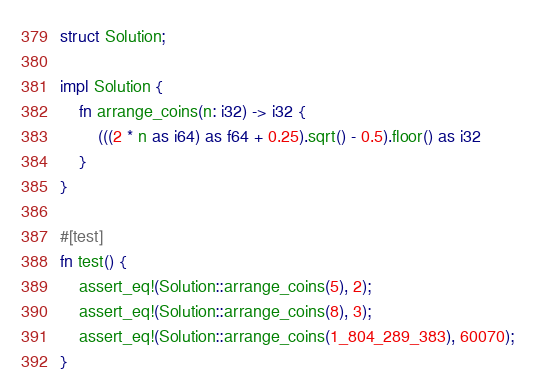<code> <loc_0><loc_0><loc_500><loc_500><_Rust_>struct Solution;

impl Solution {
    fn arrange_coins(n: i32) -> i32 {
        (((2 * n as i64) as f64 + 0.25).sqrt() - 0.5).floor() as i32
    }
}

#[test]
fn test() {
    assert_eq!(Solution::arrange_coins(5), 2);
    assert_eq!(Solution::arrange_coins(8), 3);
    assert_eq!(Solution::arrange_coins(1_804_289_383), 60070);
}
</code> 